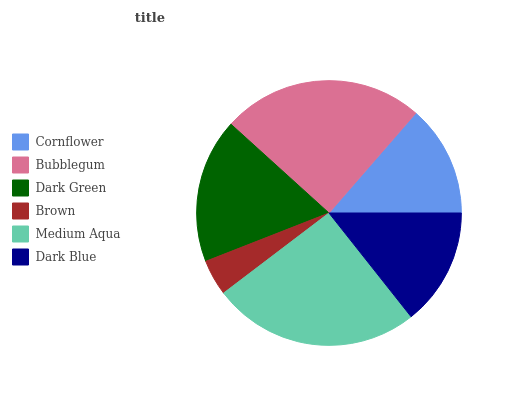Is Brown the minimum?
Answer yes or no. Yes. Is Medium Aqua the maximum?
Answer yes or no. Yes. Is Bubblegum the minimum?
Answer yes or no. No. Is Bubblegum the maximum?
Answer yes or no. No. Is Bubblegum greater than Cornflower?
Answer yes or no. Yes. Is Cornflower less than Bubblegum?
Answer yes or no. Yes. Is Cornflower greater than Bubblegum?
Answer yes or no. No. Is Bubblegum less than Cornflower?
Answer yes or no. No. Is Dark Green the high median?
Answer yes or no. Yes. Is Dark Blue the low median?
Answer yes or no. Yes. Is Cornflower the high median?
Answer yes or no. No. Is Brown the low median?
Answer yes or no. No. 